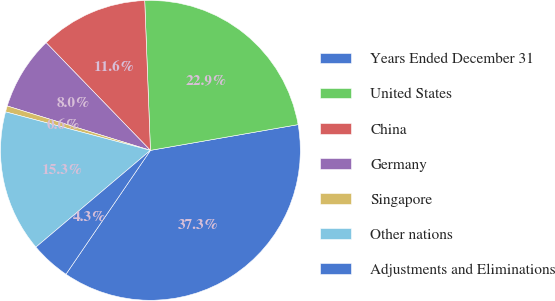Convert chart. <chart><loc_0><loc_0><loc_500><loc_500><pie_chart><fcel>Years Ended December 31<fcel>United States<fcel>China<fcel>Germany<fcel>Singapore<fcel>Other nations<fcel>Adjustments and Eliminations<nl><fcel>37.27%<fcel>22.86%<fcel>11.64%<fcel>7.97%<fcel>0.65%<fcel>15.3%<fcel>4.31%<nl></chart> 